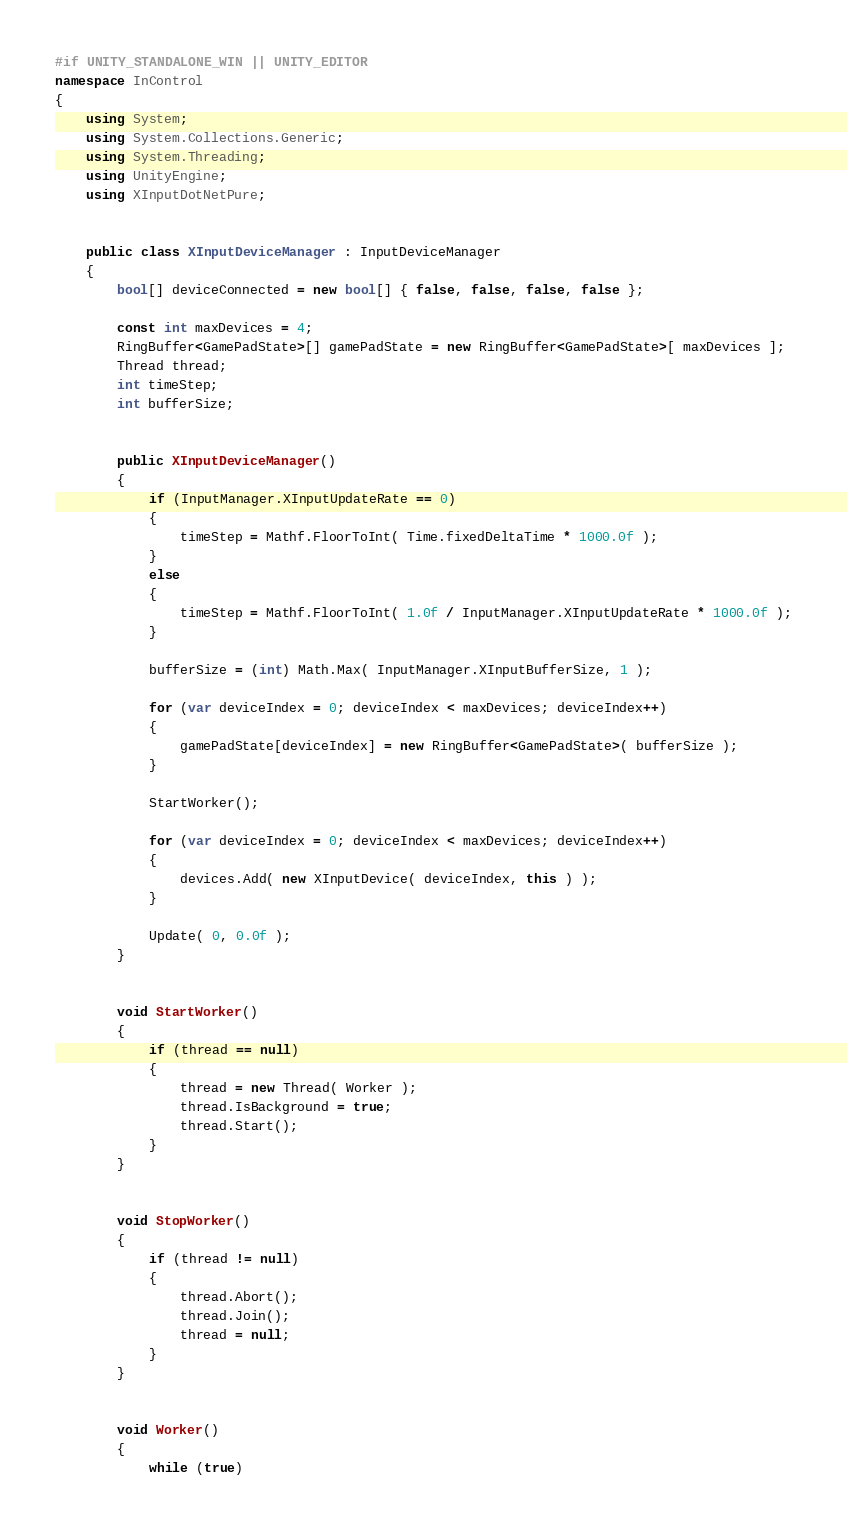Convert code to text. <code><loc_0><loc_0><loc_500><loc_500><_C#_>#if UNITY_STANDALONE_WIN || UNITY_EDITOR
namespace InControl
{
	using System;
	using System.Collections.Generic;
	using System.Threading;
	using UnityEngine;
	using XInputDotNetPure;


	public class XInputDeviceManager : InputDeviceManager
	{
		bool[] deviceConnected = new bool[] { false, false, false, false };

		const int maxDevices = 4;
		RingBuffer<GamePadState>[] gamePadState = new RingBuffer<GamePadState>[ maxDevices ];
		Thread thread;
		int timeStep;
		int bufferSize;


		public XInputDeviceManager()
		{
			if (InputManager.XInputUpdateRate == 0)
			{
				timeStep = Mathf.FloorToInt( Time.fixedDeltaTime * 1000.0f );
			}
			else
			{
				timeStep = Mathf.FloorToInt( 1.0f / InputManager.XInputUpdateRate * 1000.0f );
			}

			bufferSize = (int) Math.Max( InputManager.XInputBufferSize, 1 );

			for (var deviceIndex = 0; deviceIndex < maxDevices; deviceIndex++)
			{
				gamePadState[deviceIndex] = new RingBuffer<GamePadState>( bufferSize );
			}

			StartWorker();

			for (var deviceIndex = 0; deviceIndex < maxDevices; deviceIndex++)
			{
				devices.Add( new XInputDevice( deviceIndex, this ) );
			}

			Update( 0, 0.0f );
		}


		void StartWorker()
		{
			if (thread == null)
			{
				thread = new Thread( Worker );
				thread.IsBackground = true;
				thread.Start();
			}
		}


		void StopWorker()
		{
			if (thread != null)
			{
				thread.Abort();
				thread.Join();
				thread = null;
			}
		}


		void Worker()
		{
			while (true)</code> 